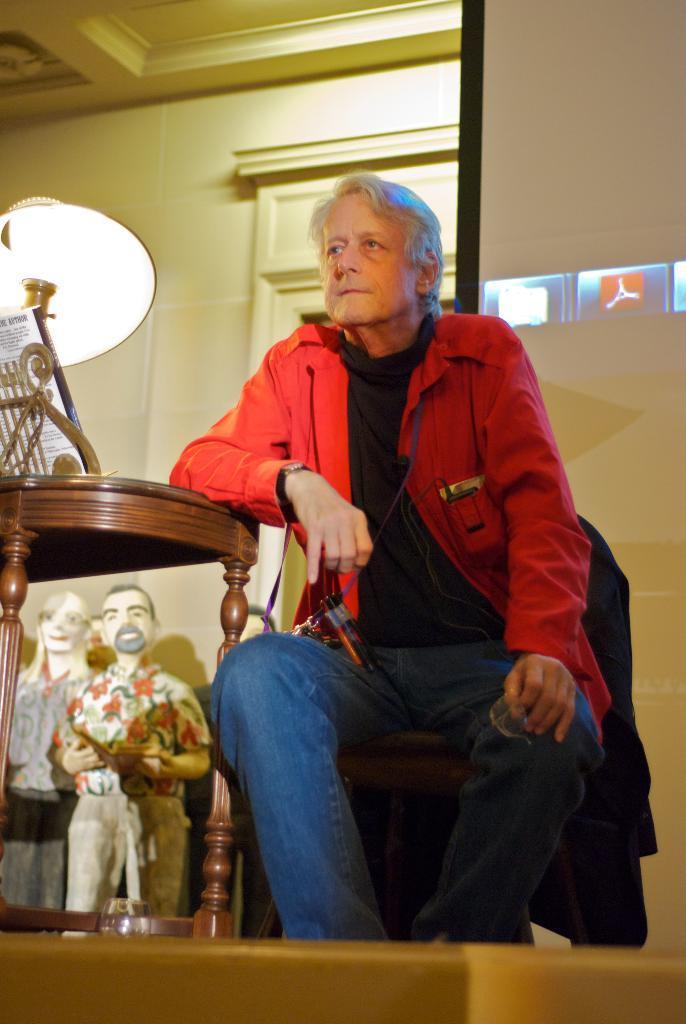Can you describe this image briefly? In this image there is a person sitting on chair, beside him there is a table with lamp and some sculptures under that. 